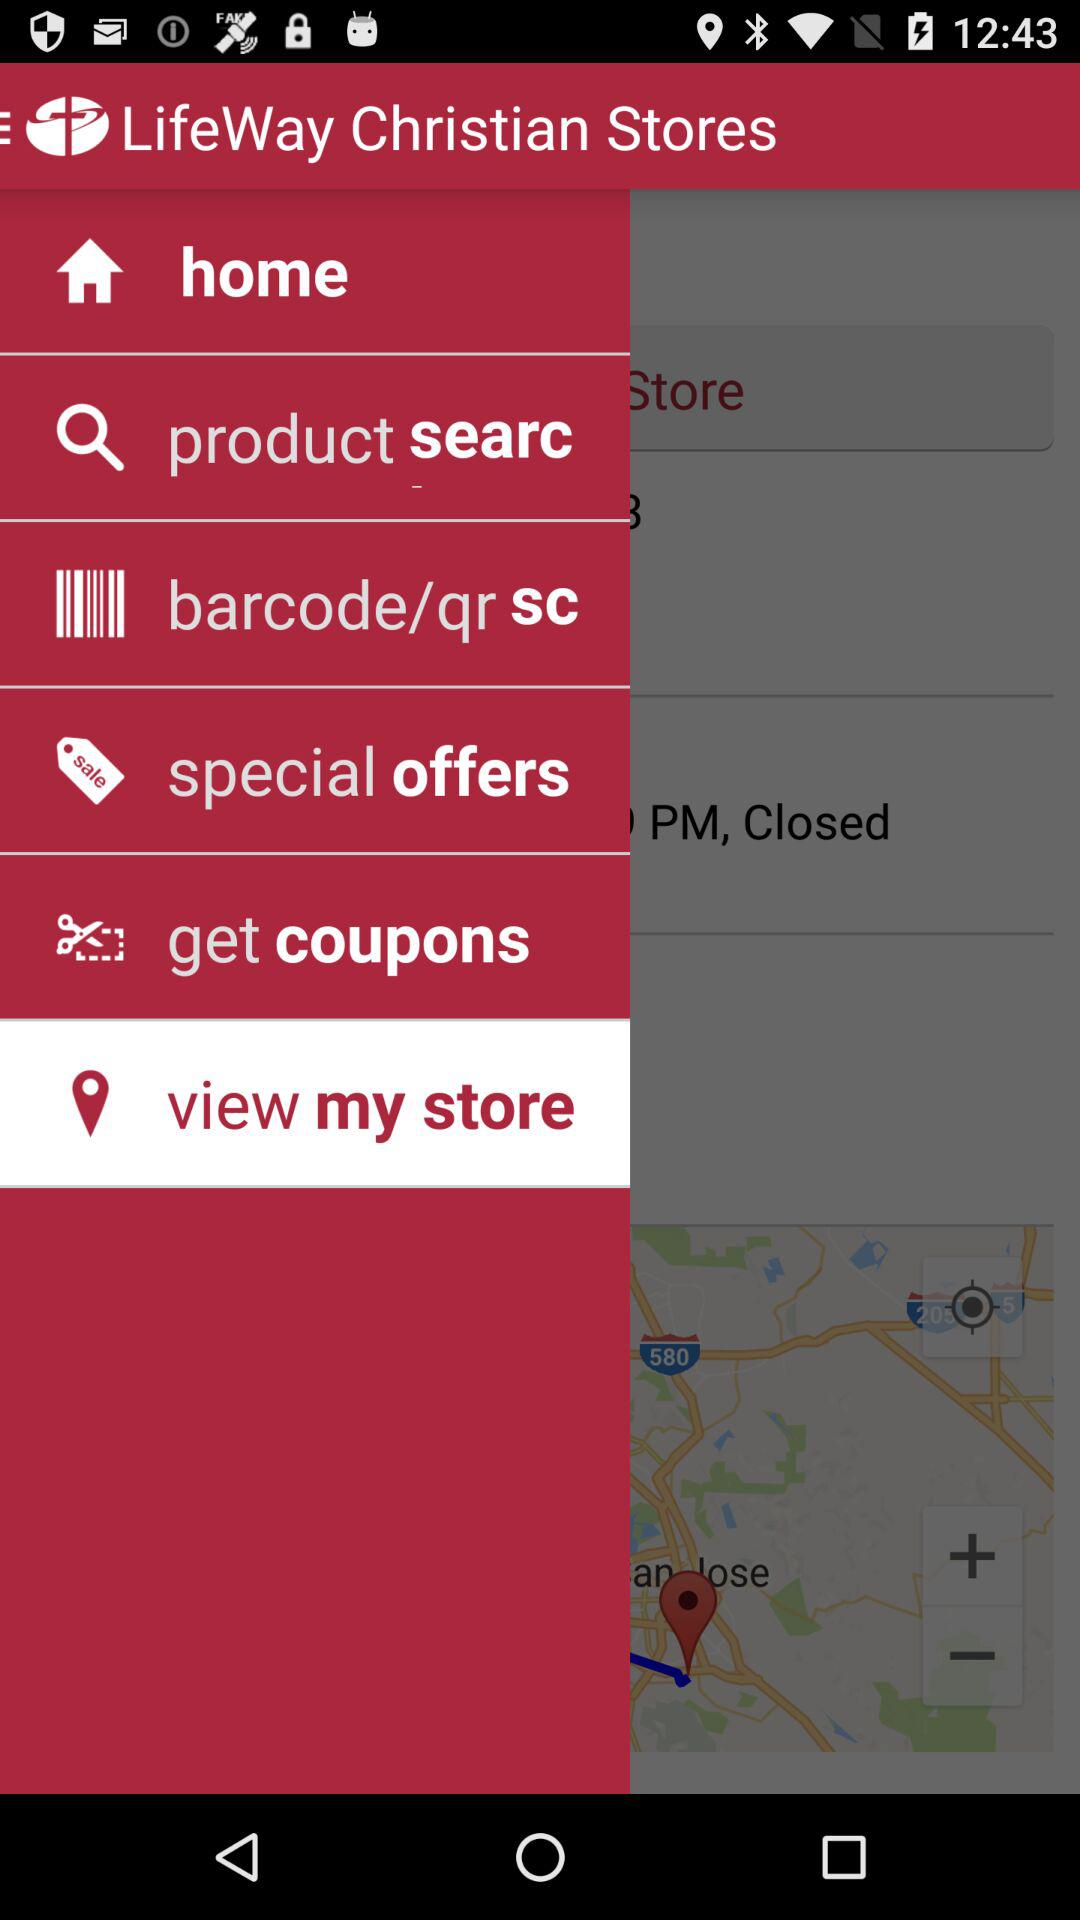Which option is selected? The selected option is "view my store". 